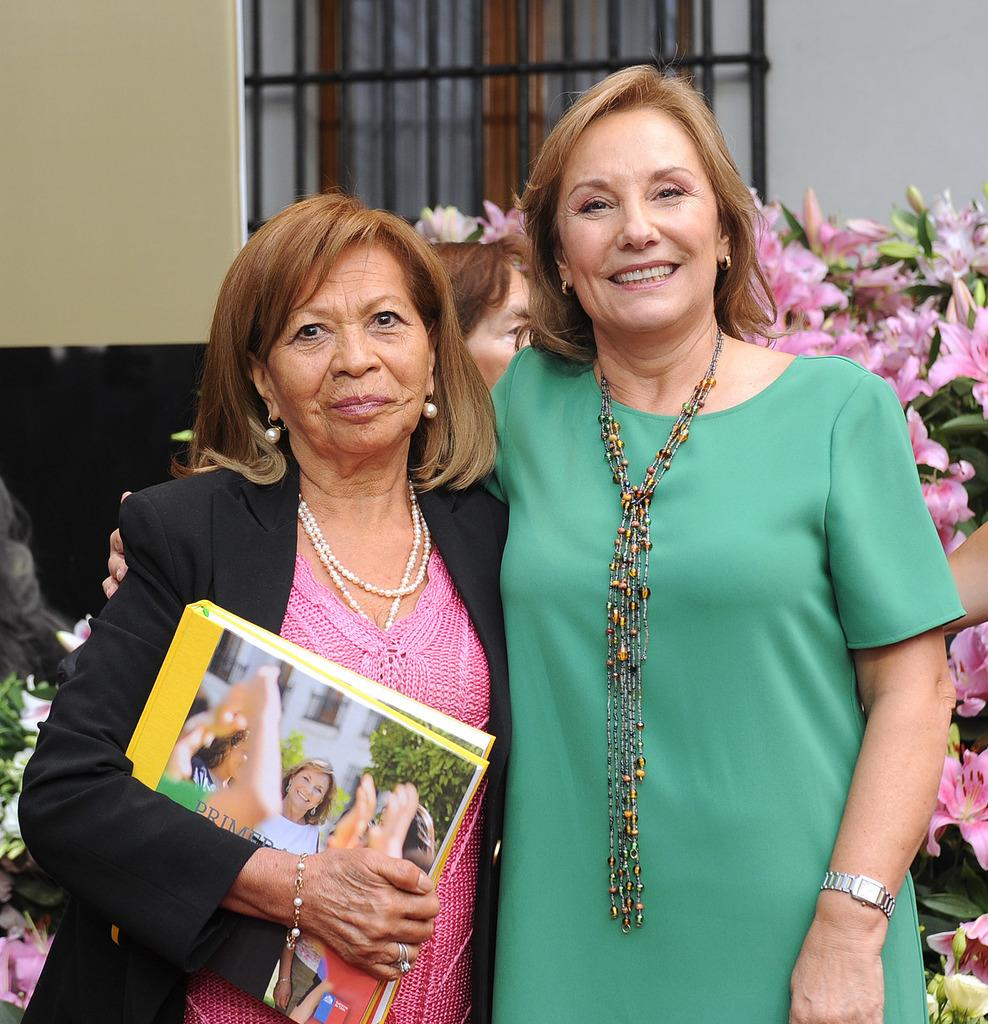How many people are present in the image? There are two persons standing in the image. What is one of the persons holding? There is a person holding a book in the image. Can you describe the background of the image? There are flowers visible in the background, along with a window and a wall. Is there anyone else in the background of the image? Yes, there is another person in the background of the image. What type of cord is being used to tie the oatmeal in the middle of the image? There is no cord or oatmeal present in the image. 